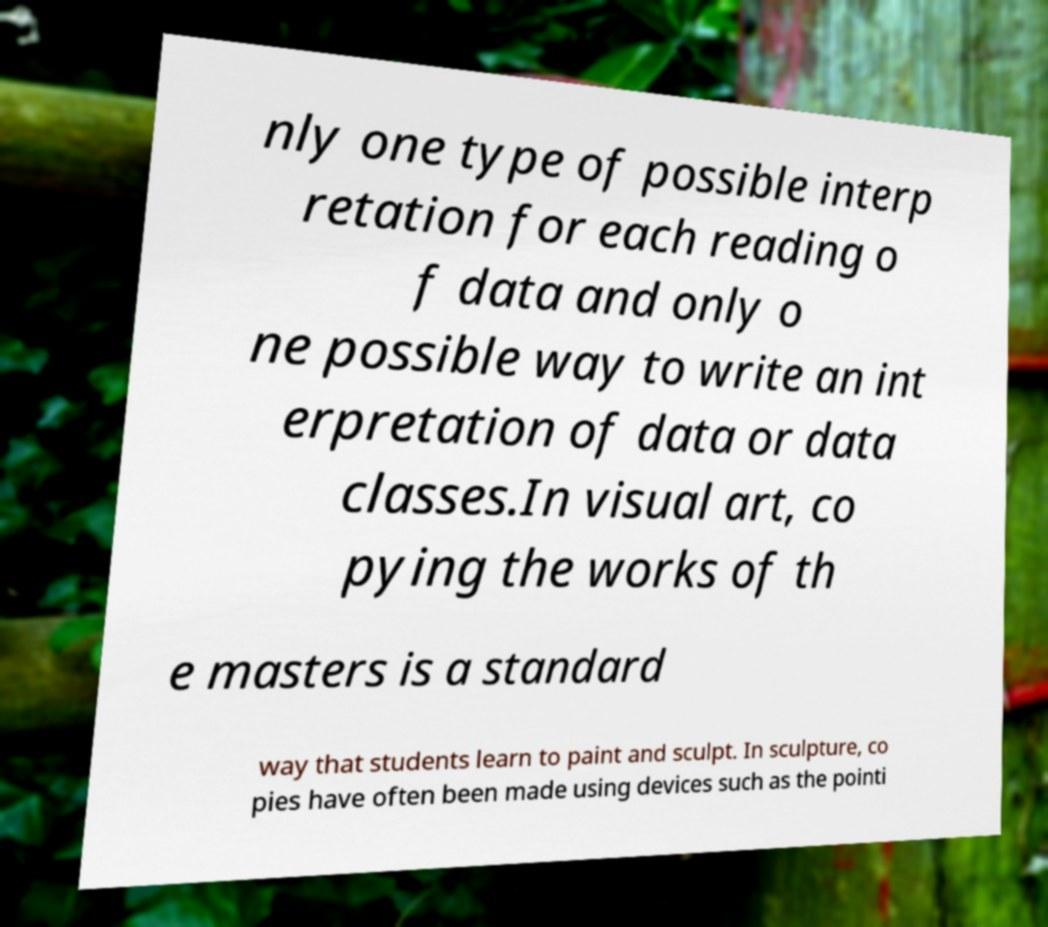Could you extract and type out the text from this image? nly one type of possible interp retation for each reading o f data and only o ne possible way to write an int erpretation of data or data classes.In visual art, co pying the works of th e masters is a standard way that students learn to paint and sculpt. In sculpture, co pies have often been made using devices such as the pointi 